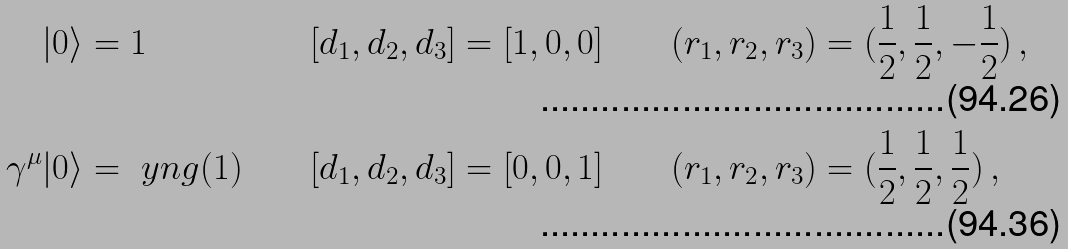<formula> <loc_0><loc_0><loc_500><loc_500>| 0 \rangle & = 1 & \quad [ d _ { 1 } , d _ { 2 } , d _ { 3 } ] & = [ 1 , 0 , 0 ] & \quad ( r _ { 1 } , r _ { 2 } , r _ { 3 } ) & = ( \frac { 1 } { 2 } , \frac { 1 } { 2 } , - \frac { 1 } { 2 } ) \, , \\ \gamma ^ { \mu } | 0 \rangle & = \ y n g ( 1 ) & \quad [ d _ { 1 } , d _ { 2 } , d _ { 3 } ] & = [ 0 , 0 , 1 ] & ( r _ { 1 } , r _ { 2 } , r _ { 3 } ) & = ( \frac { 1 } { 2 } , \frac { 1 } { 2 } , \frac { 1 } { 2 } ) \, ,</formula> 